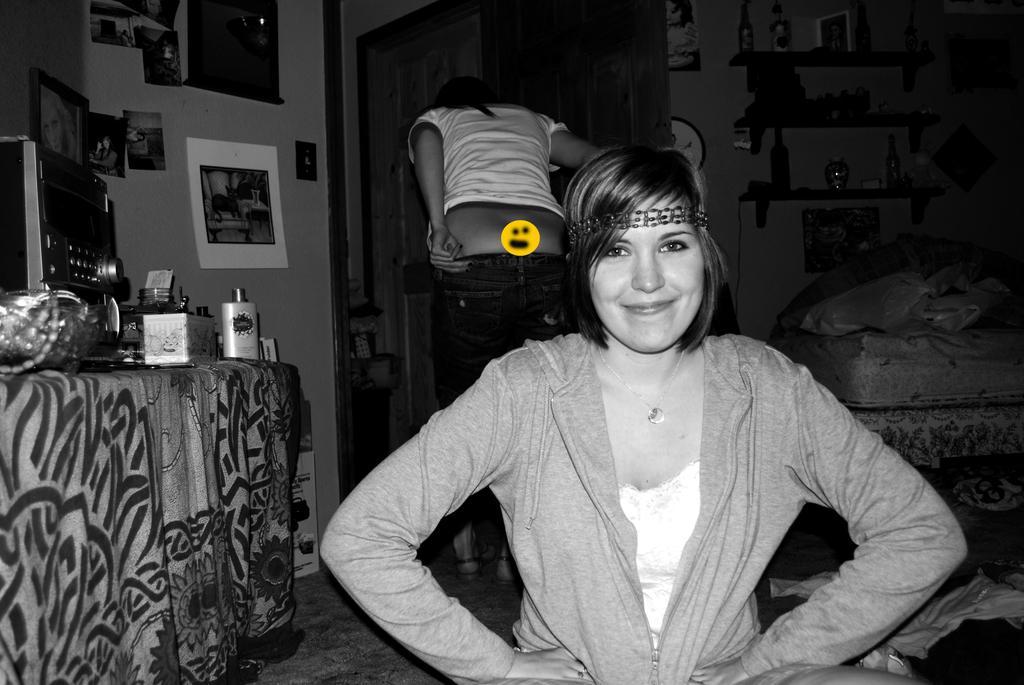Could you give a brief overview of what you see in this image? This is a black and white image. Here I can see a woman sitting. smiling and giving pose for the picture. In the background, I can see another person is standing. On the left side there is a table which is covered with a cloth. On the table I can see a coffee machine and some more objects. To the right side there is a bed. In the background, I can see few posts are attached to the wall and also there is a rack in which few bottles are arranged. 